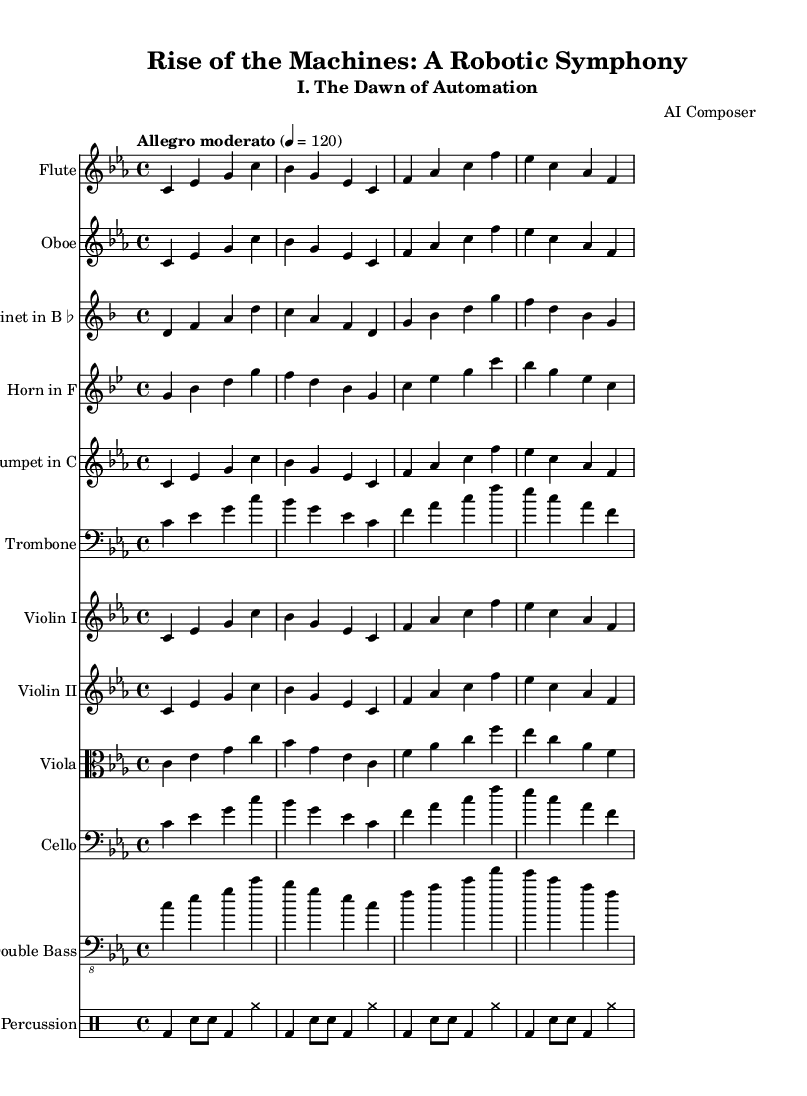What is the key signature of this music? The key signature is C minor, which has three flats: B♭, E♭, and A♭. This can be identified by looking at the key signature at the beginning of the staff.
Answer: C minor What is the time signature of this music? The time signature is 4/4, indicating that there are four beats in each measure and the quarter note gets one beat. This is shown at the beginning of the score.
Answer: 4/4 What is the tempo marking for this piece? The tempo marking is "Allegro moderato", which indicates a moderately fast tempo. This can be found at the beginning of the score, below the title.
Answer: Allegro moderato How many staves are present in the score? There are eleven staves in total. This includes individual staves for each instrument as listed in the score and one for percussion. Counting each distinct staff gives the total of eleven.
Answer: 11 Which instruments are featured in this symphonic work? The featured instruments are Flute, Oboe, Clarinet in B♭, Horn in F, Trumpet in C, Trombone, Violin I, Violin II, Viola, Cello, Double Bass, and Percussion. Each instrument has a separate staff, which is indicated in the score.
Answer: Flute, Oboe, Clarinet in B♭, Horn in F, Trumpet in C, Trombone, Violin I, Violin II, Viola, Cello, Double Bass, Percussion What is the main theme melody's initial note? The initial note of the main theme melody is C. This is determined by looking at the first note in the relative pitch notation of the main theme.
Answer: C How does this symphonic work depict robotics evolution? The piece is titled "Rise of the Machines: A Robotic Symphony", suggesting that the music expresses themes associated with robotics and automation throughout history. The title and subtitle indicate a narrative focus on robotics.
Answer: Robotics and automation themes 